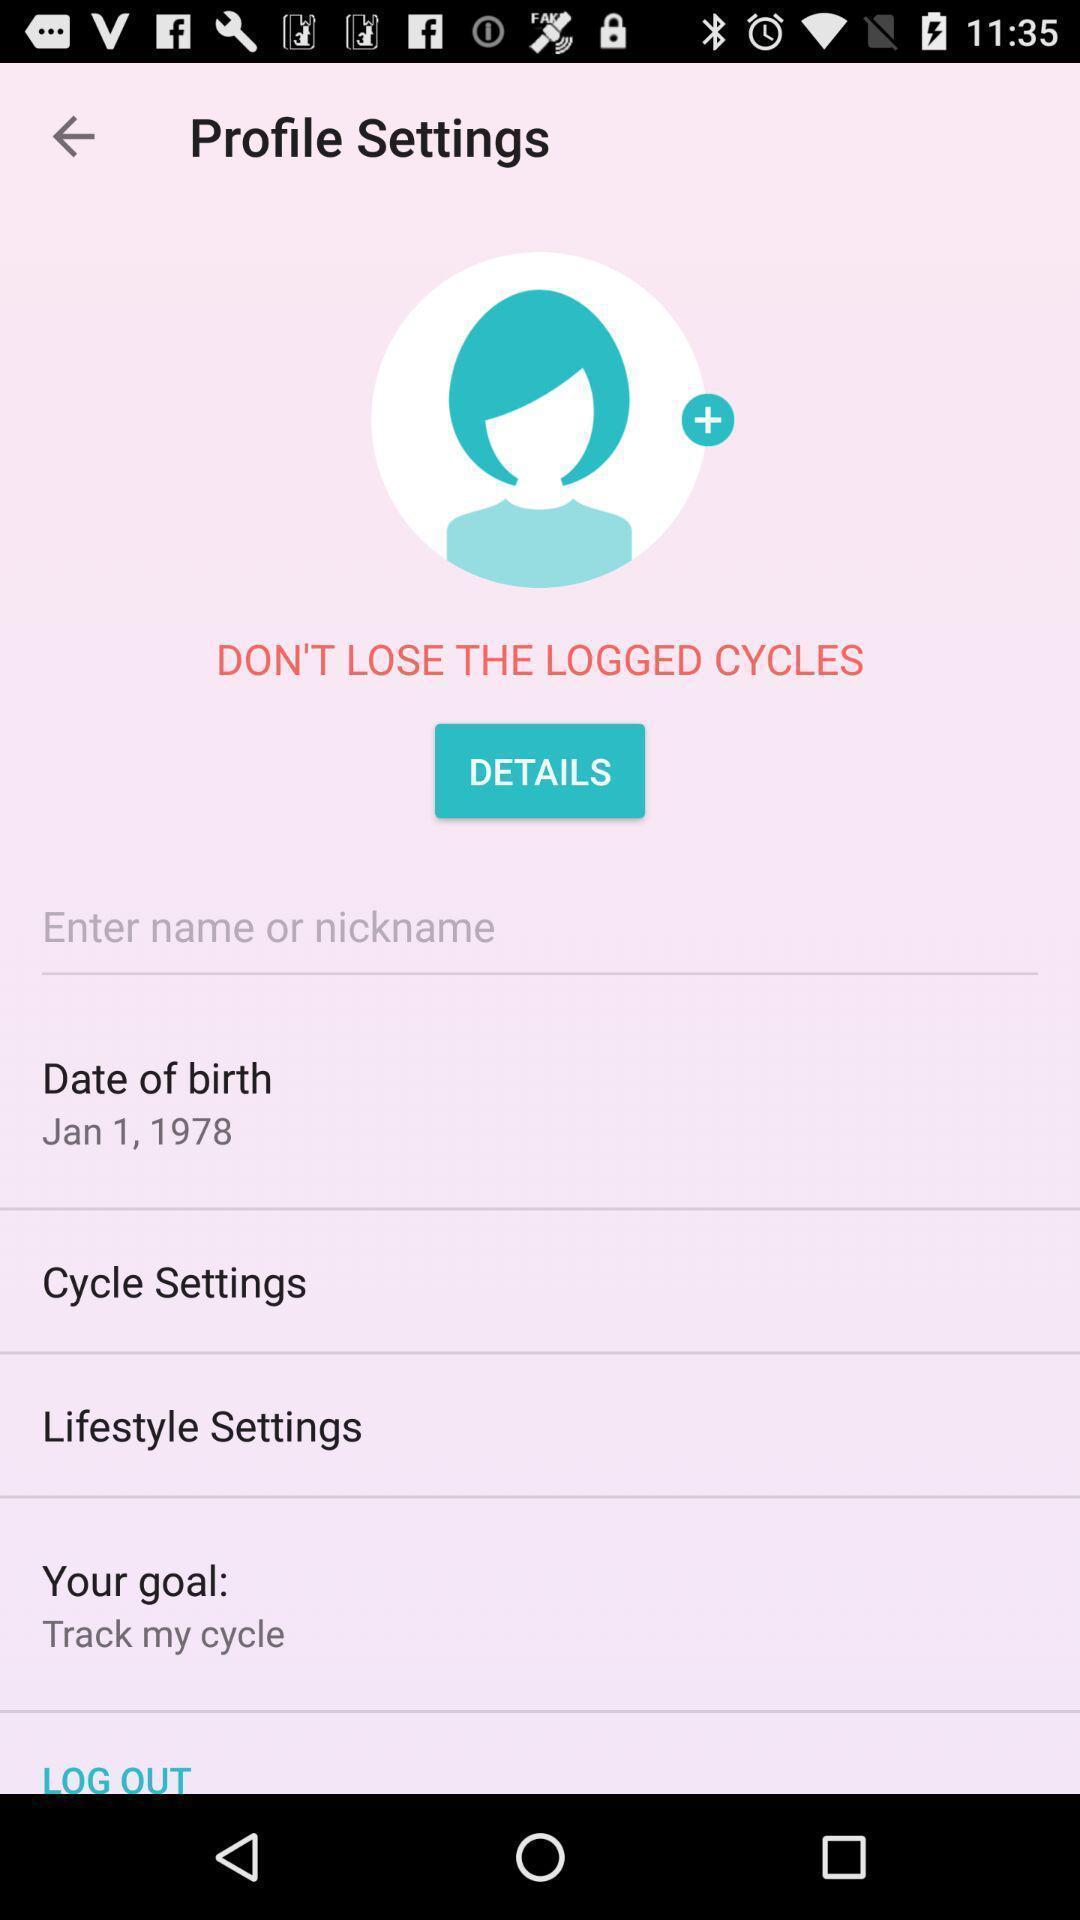Give me a narrative description of this picture. Settings page of profile in period tracker application. 